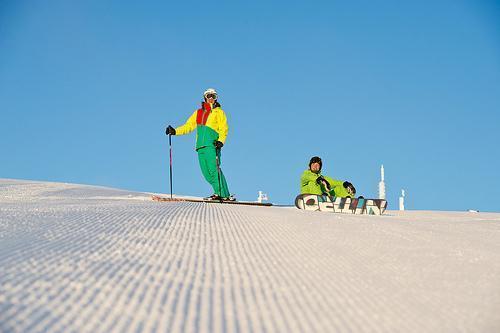How many held poles?
Give a very brief answer. 2. How many people are there?
Give a very brief answer. 2. How many people have ski poles?
Give a very brief answer. 1. How many white poles are seen?
Give a very brief answer. 3. 